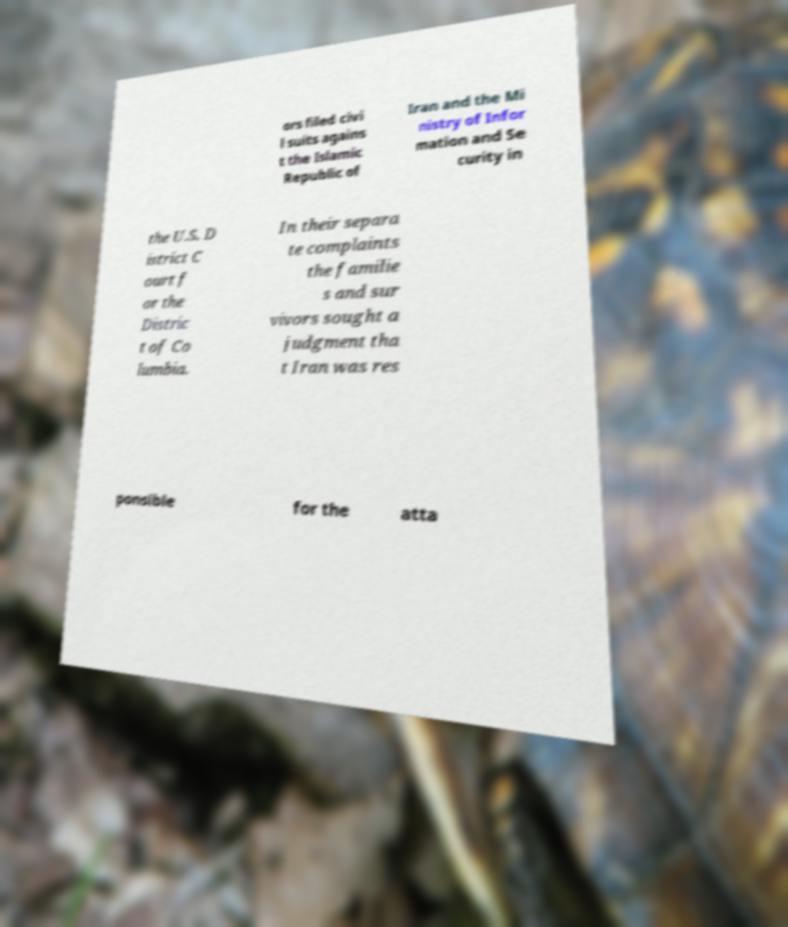Could you extract and type out the text from this image? ors filed civi l suits agains t the Islamic Republic of Iran and the Mi nistry of Infor mation and Se curity in the U.S. D istrict C ourt f or the Distric t of Co lumbia. In their separa te complaints the familie s and sur vivors sought a judgment tha t Iran was res ponsible for the atta 